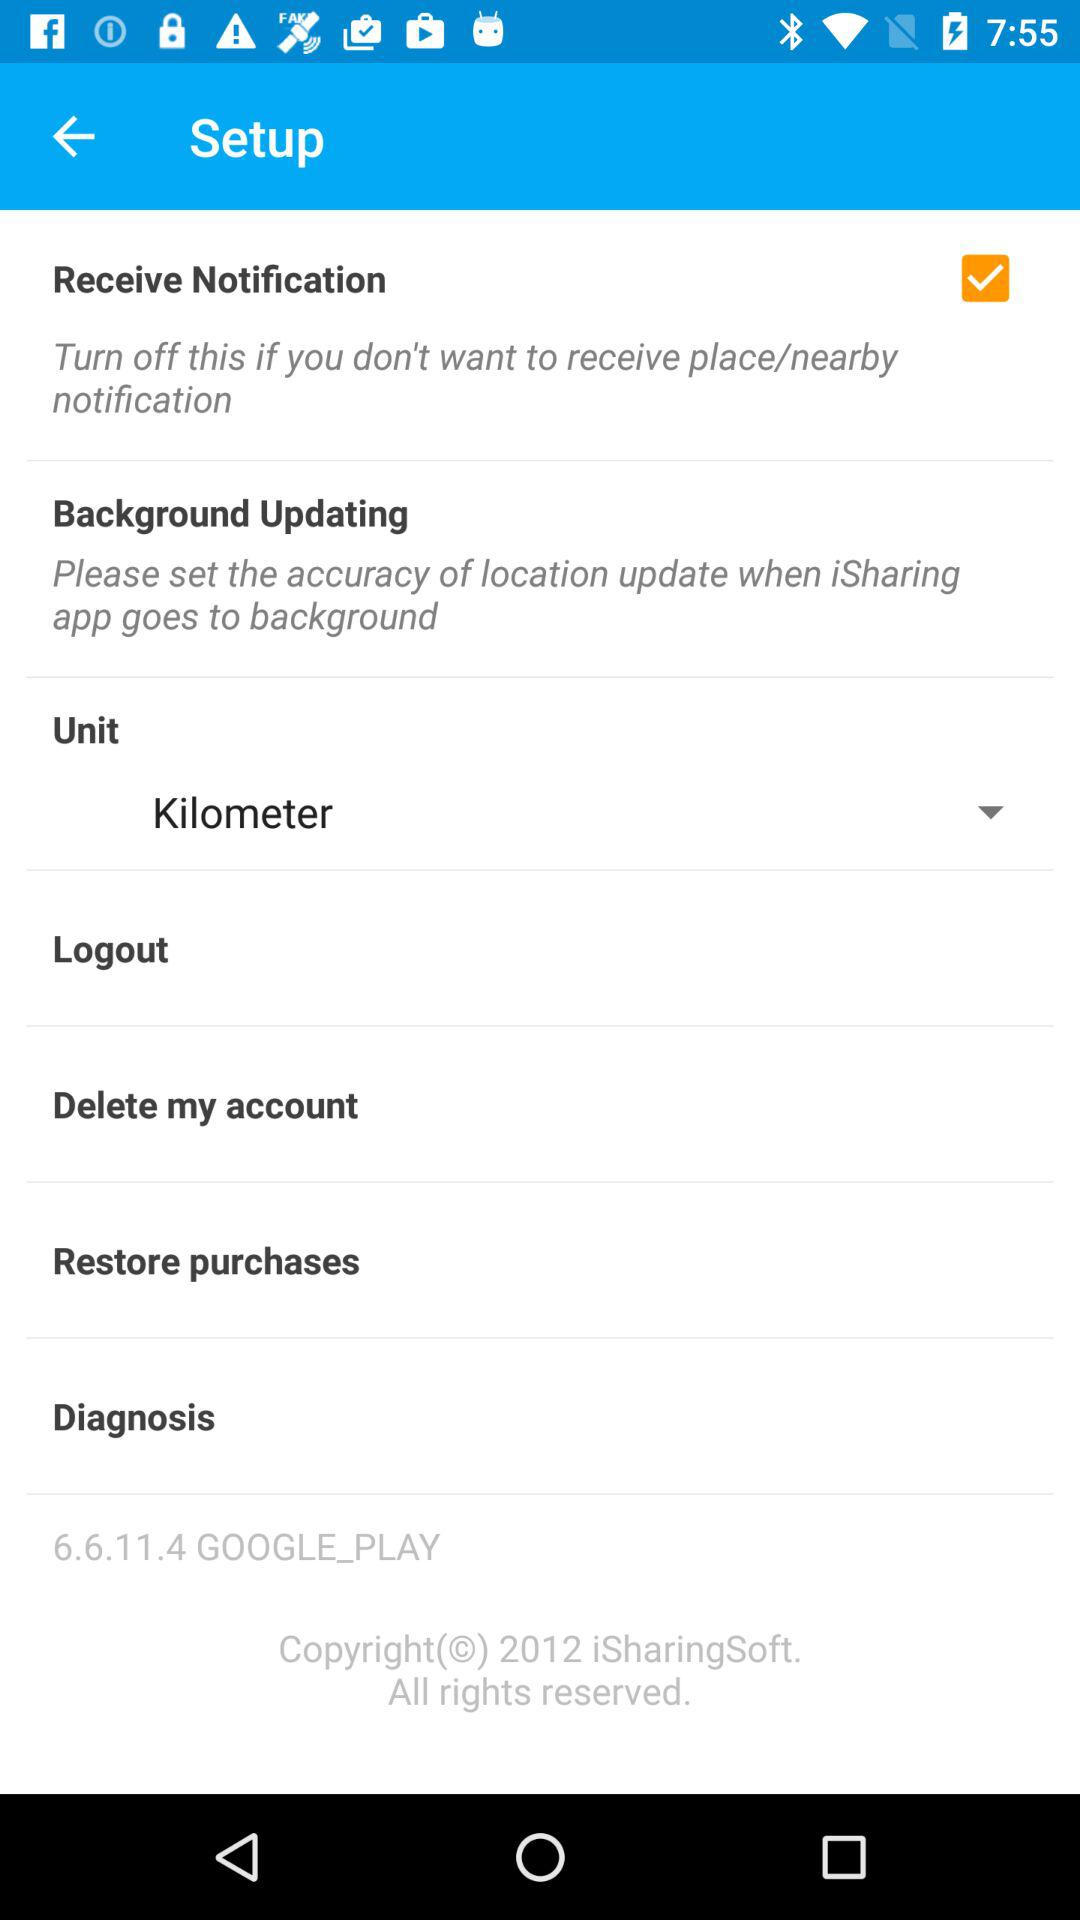What is the selected unit? The selected unit is the kilometer. 